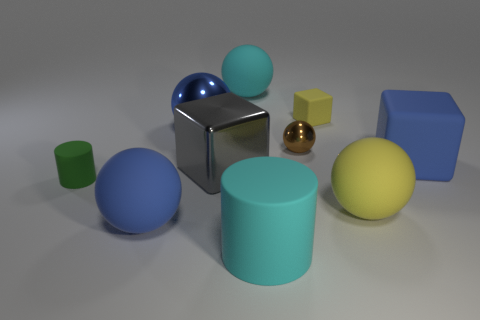Is the number of green rubber things that are left of the brown ball greater than the number of small brown cubes?
Your answer should be very brief. Yes. There is a rubber ball that is behind the green rubber object; what color is it?
Provide a succinct answer. Cyan. What number of metallic things are small gray objects or cylinders?
Ensure brevity in your answer.  0. There is a blue rubber object that is on the right side of the big rubber thing in front of the large blue matte sphere; is there a big cyan cylinder that is right of it?
Your response must be concise. No. There is a small cube; what number of blue balls are on the left side of it?
Your answer should be very brief. 2. There is a object that is the same color as the big matte cylinder; what is it made of?
Ensure brevity in your answer.  Rubber. What number of large objects are either gray cubes or blue balls?
Make the answer very short. 3. There is a big thing left of the blue metallic thing; what is its shape?
Provide a short and direct response. Sphere. Is there a big thing that has the same color as the big matte block?
Offer a very short reply. Yes. There is a blue rubber object that is in front of the yellow ball; is its size the same as the green object that is on the left side of the yellow ball?
Your answer should be compact. No. 